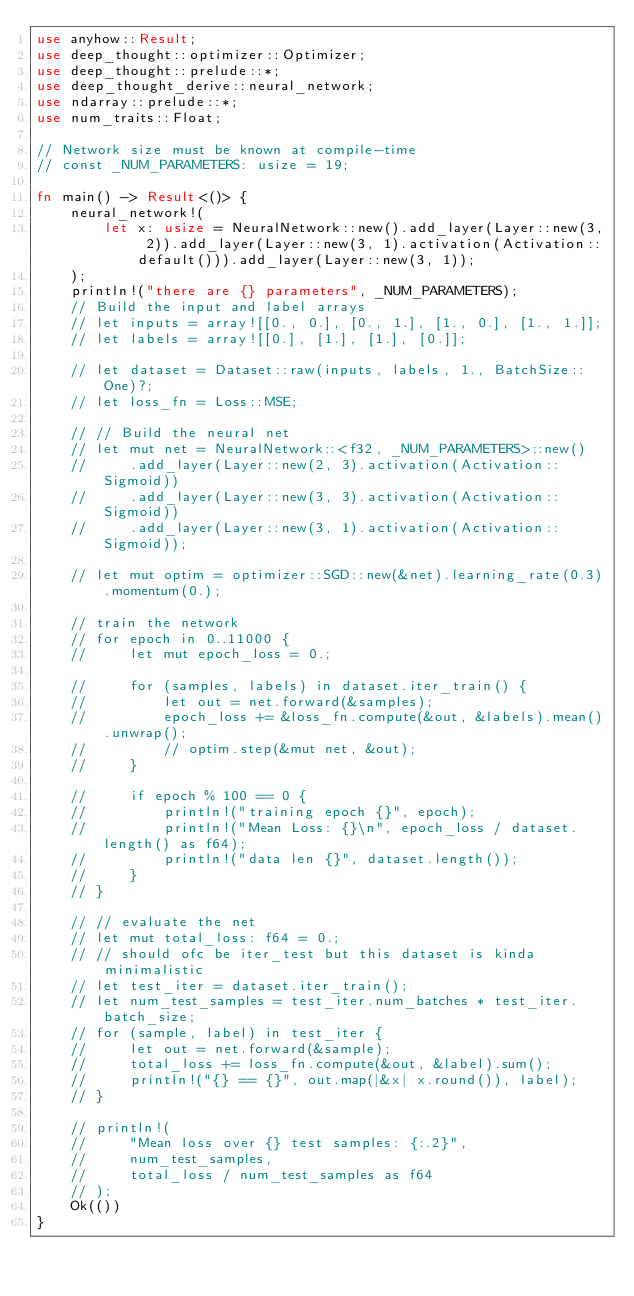Convert code to text. <code><loc_0><loc_0><loc_500><loc_500><_Rust_>use anyhow::Result;
use deep_thought::optimizer::Optimizer;
use deep_thought::prelude::*;
use deep_thought_derive::neural_network;
use ndarray::prelude::*;
use num_traits::Float;

// Network size must be known at compile-time
// const _NUM_PARAMETERS: usize = 19;

fn main() -> Result<()> {
    neural_network!(
        let x: usize = NeuralNetwork::new().add_layer(Layer::new(3, 2)).add_layer(Layer::new(3, 1).activation(Activation::default())).add_layer(Layer::new(3, 1));
    );
    println!("there are {} parameters", _NUM_PARAMETERS);
    // Build the input and label arrays
    // let inputs = array![[0., 0.], [0., 1.], [1., 0.], [1., 1.]];
    // let labels = array![[0.], [1.], [1.], [0.]];

    // let dataset = Dataset::raw(inputs, labels, 1., BatchSize::One)?;
    // let loss_fn = Loss::MSE;

    // // Build the neural net
    // let mut net = NeuralNetwork::<f32, _NUM_PARAMETERS>::new()
    //     .add_layer(Layer::new(2, 3).activation(Activation::Sigmoid))
    //     .add_layer(Layer::new(3, 3).activation(Activation::Sigmoid))
    //     .add_layer(Layer::new(3, 1).activation(Activation::Sigmoid));

    // let mut optim = optimizer::SGD::new(&net).learning_rate(0.3).momentum(0.);

    // train the network
    // for epoch in 0..11000 {
    //     let mut epoch_loss = 0.;

    //     for (samples, labels) in dataset.iter_train() {
    //         let out = net.forward(&samples);
    //         epoch_loss += &loss_fn.compute(&out, &labels).mean().unwrap();
    //         // optim.step(&mut net, &out);
    //     }

    //     if epoch % 100 == 0 {
    //         println!("training epoch {}", epoch);
    //         println!("Mean Loss: {}\n", epoch_loss / dataset.length() as f64);
    //         println!("data len {}", dataset.length());
    //     }
    // }

    // // evaluate the net
    // let mut total_loss: f64 = 0.;
    // // should ofc be iter_test but this dataset is kinda minimalistic
    // let test_iter = dataset.iter_train();
    // let num_test_samples = test_iter.num_batches * test_iter.batch_size;
    // for (sample, label) in test_iter {
    //     let out = net.forward(&sample);
    //     total_loss += loss_fn.compute(&out, &label).sum();
    //     println!("{} == {}", out.map(|&x| x.round()), label);
    // }

    // println!(
    //     "Mean loss over {} test samples: {:.2}",
    //     num_test_samples,
    //     total_loss / num_test_samples as f64
    // );
    Ok(())
}
</code> 